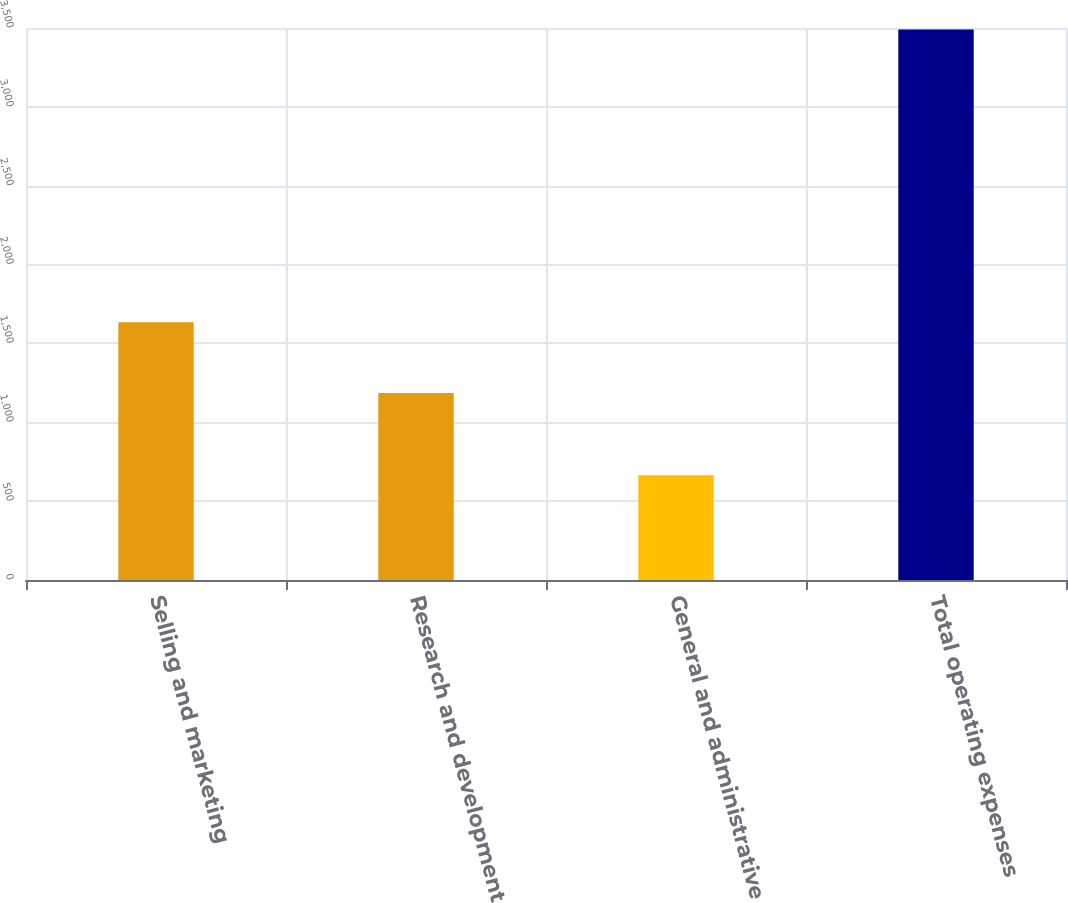Convert chart to OTSL. <chart><loc_0><loc_0><loc_500><loc_500><bar_chart><fcel>Selling and marketing<fcel>Research and development<fcel>General and administrative<fcel>Total operating expenses<nl><fcel>1634<fcel>1186<fcel>664<fcel>3490<nl></chart> 